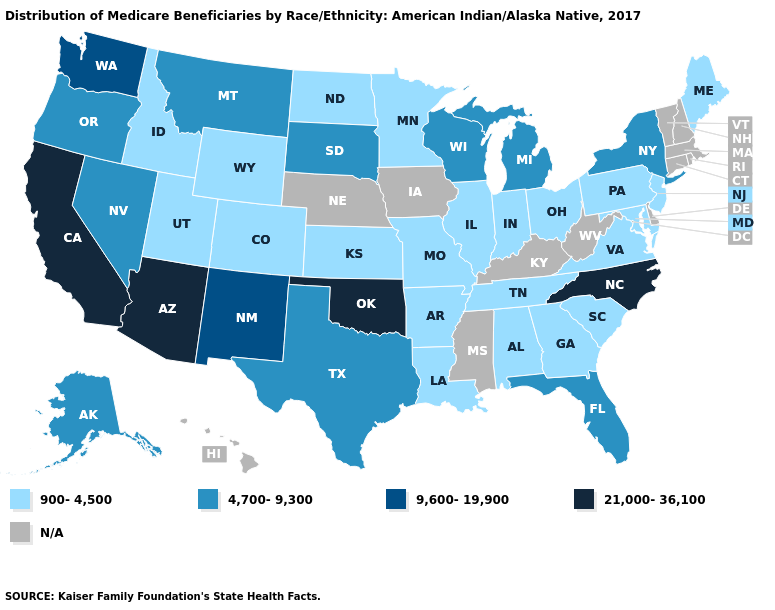What is the value of Iowa?
Quick response, please. N/A. Name the states that have a value in the range 21,000-36,100?
Answer briefly. Arizona, California, North Carolina, Oklahoma. What is the value of Missouri?
Concise answer only. 900-4,500. Which states hav the highest value in the Northeast?
Write a very short answer. New York. Which states have the lowest value in the Northeast?
Write a very short answer. Maine, New Jersey, Pennsylvania. Name the states that have a value in the range N/A?
Concise answer only. Connecticut, Delaware, Hawaii, Iowa, Kentucky, Massachusetts, Mississippi, Nebraska, New Hampshire, Rhode Island, Vermont, West Virginia. What is the value of Virginia?
Quick response, please. 900-4,500. Among the states that border Louisiana , which have the lowest value?
Answer briefly. Arkansas. Name the states that have a value in the range N/A?
Give a very brief answer. Connecticut, Delaware, Hawaii, Iowa, Kentucky, Massachusetts, Mississippi, Nebraska, New Hampshire, Rhode Island, Vermont, West Virginia. Which states hav the highest value in the South?
Quick response, please. North Carolina, Oklahoma. Does North Carolina have the lowest value in the South?
Write a very short answer. No. Name the states that have a value in the range 9,600-19,900?
Write a very short answer. New Mexico, Washington. Does Missouri have the highest value in the MidWest?
Answer briefly. No. What is the lowest value in the Northeast?
Answer briefly. 900-4,500. What is the highest value in the USA?
Short answer required. 21,000-36,100. 